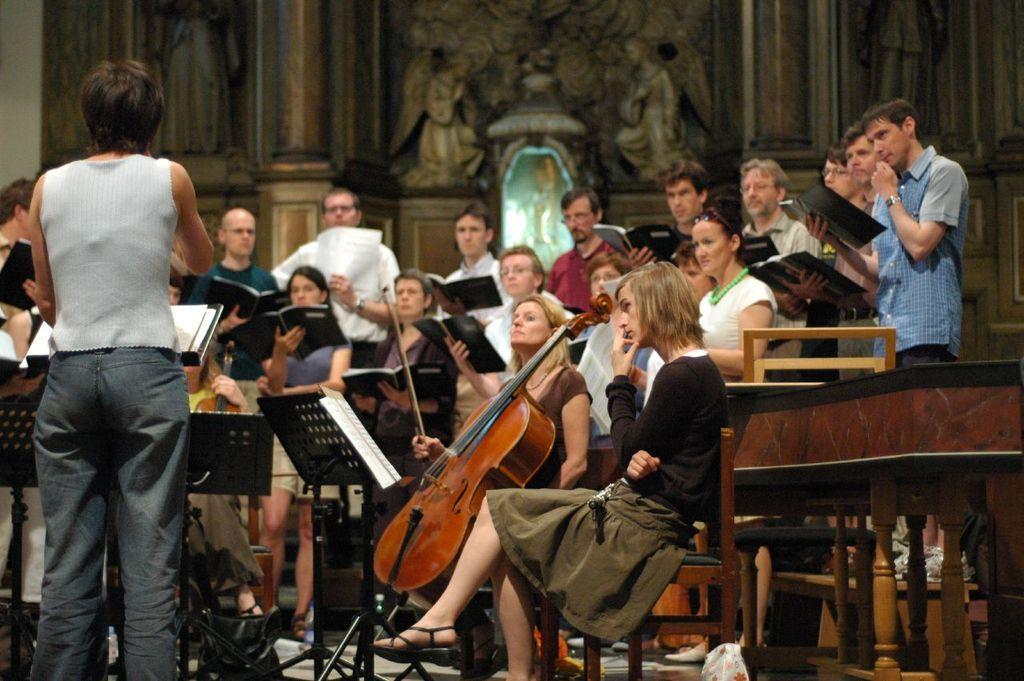Can you describe this image briefly? In this picture we can see a group of people holding books and standing and some people sitting on the chairs holding some musical instruments and a lady standing in front of them holding a mike. 